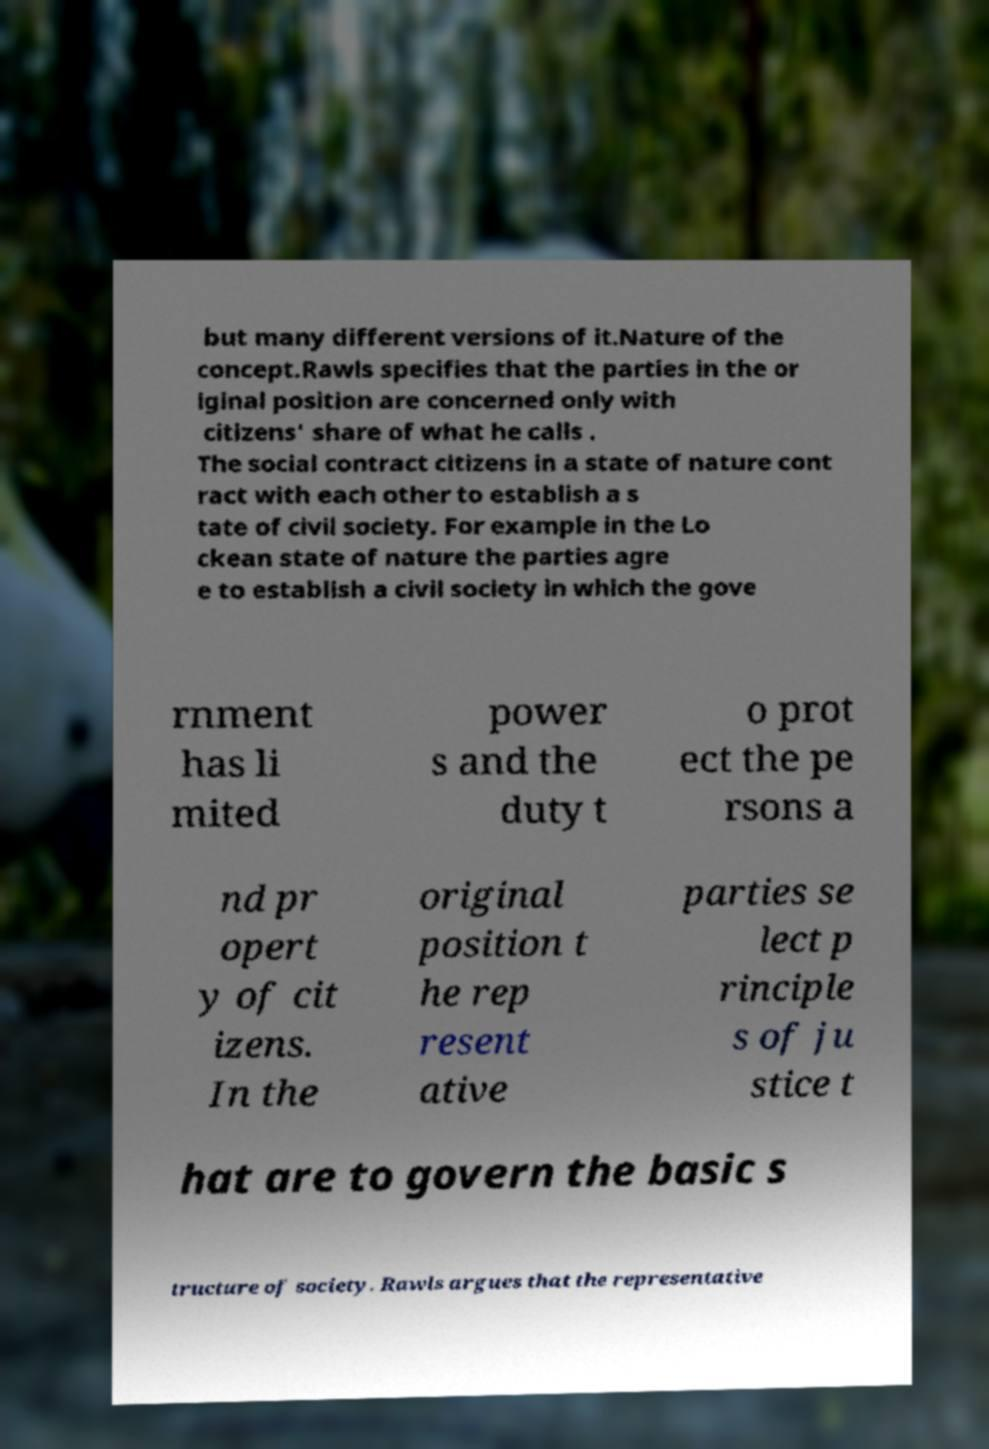I need the written content from this picture converted into text. Can you do that? but many different versions of it.Nature of the concept.Rawls specifies that the parties in the or iginal position are concerned only with citizens' share of what he calls . The social contract citizens in a state of nature cont ract with each other to establish a s tate of civil society. For example in the Lo ckean state of nature the parties agre e to establish a civil society in which the gove rnment has li mited power s and the duty t o prot ect the pe rsons a nd pr opert y of cit izens. In the original position t he rep resent ative parties se lect p rinciple s of ju stice t hat are to govern the basic s tructure of society. Rawls argues that the representative 